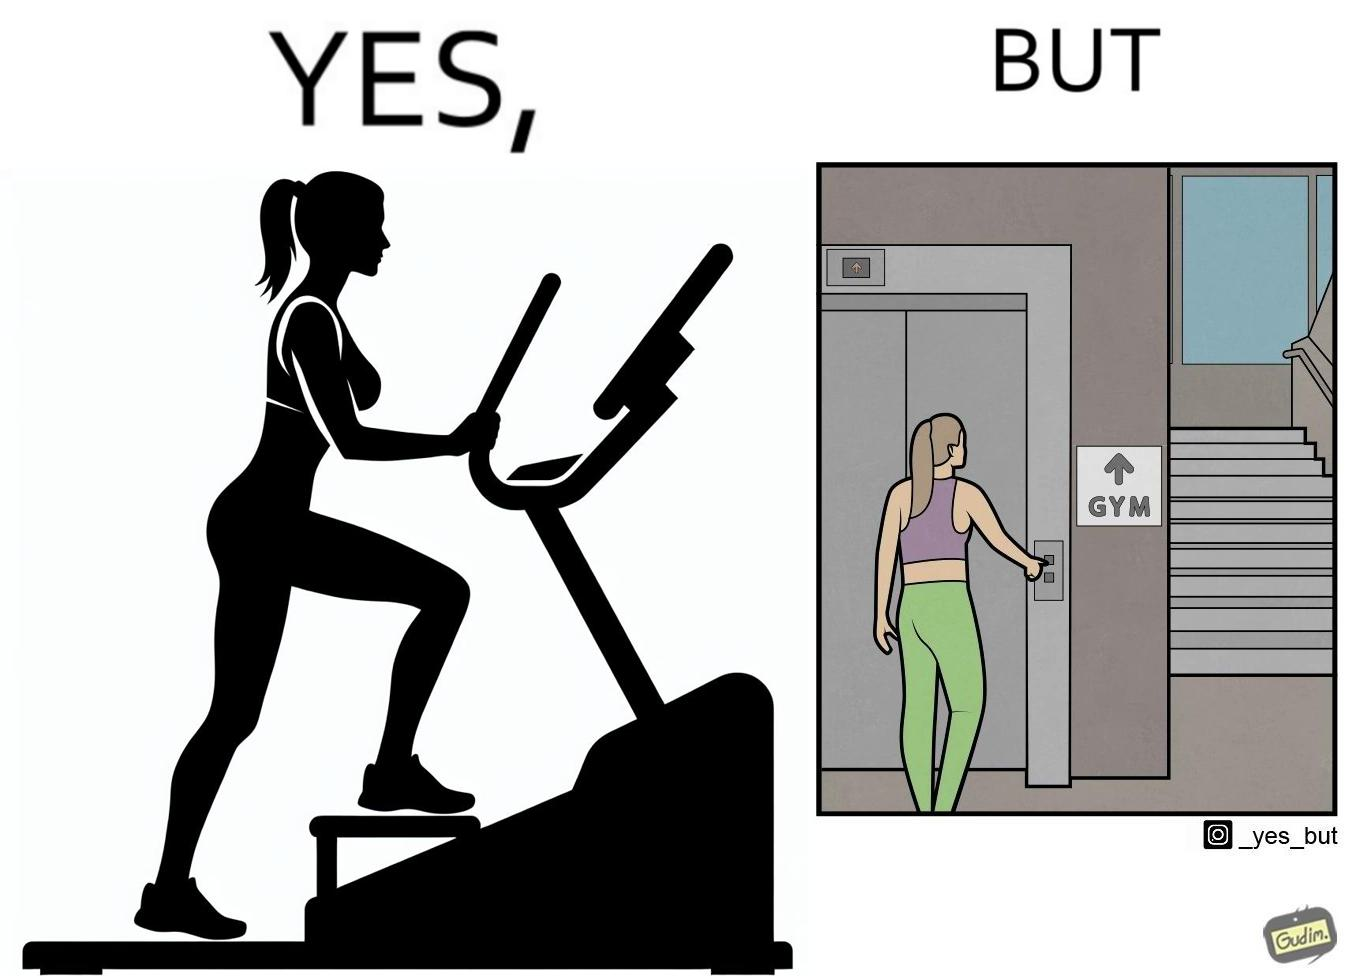What makes this image funny or satirical? The image is ironic, because in the left image a woman is seen using the stair climber machine at the gym but the same woman is not ready to climb up some stairs for going to the gym and is calling for the lift 